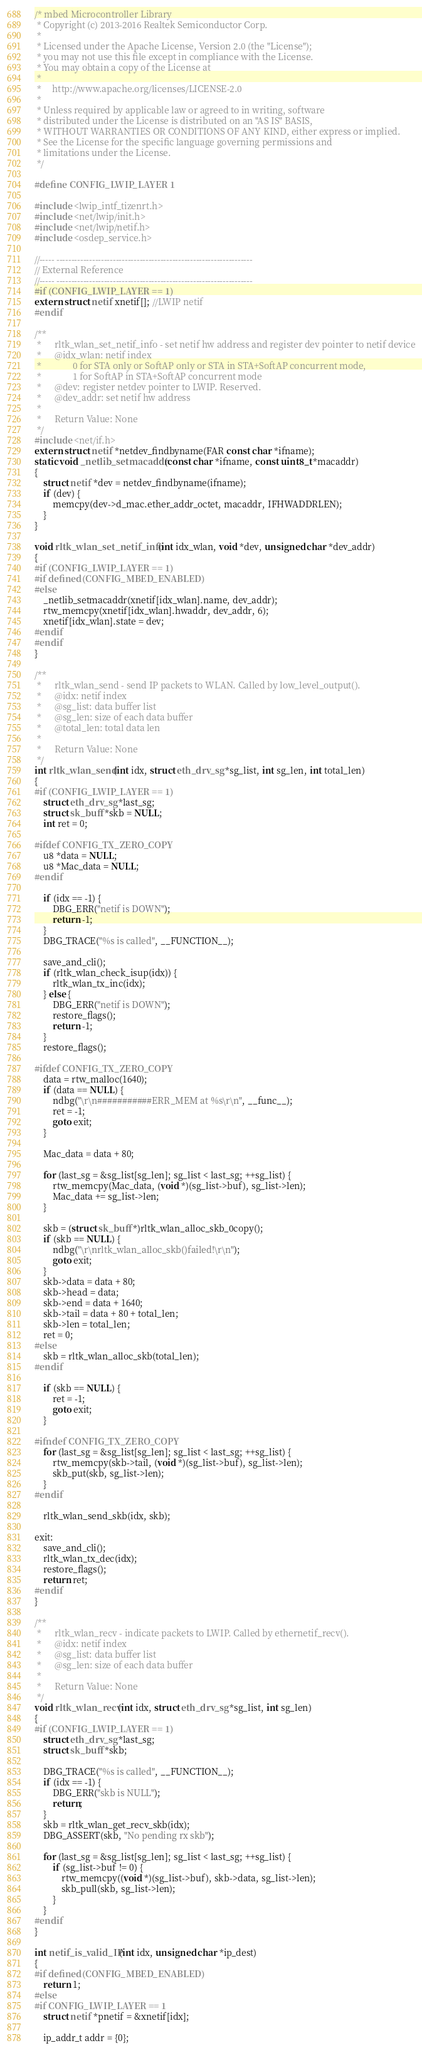<code> <loc_0><loc_0><loc_500><loc_500><_C_>/* mbed Microcontroller Library
 * Copyright (c) 2013-2016 Realtek Semiconductor Corp.
 *
 * Licensed under the Apache License, Version 2.0 (the "License");
 * you may not use this file except in compliance with the License.
 * You may obtain a copy of the License at
 *
 *     http://www.apache.org/licenses/LICENSE-2.0
 *
 * Unless required by applicable law or agreed to in writing, software
 * distributed under the License is distributed on an "AS IS" BASIS,
 * WITHOUT WARRANTIES OR CONDITIONS OF ANY KIND, either express or implied.
 * See the License for the specific language governing permissions and
 * limitations under the License.
 */

#define CONFIG_LWIP_LAYER 1

#include <lwip_intf_tizenrt.h>
#include <net/lwip/init.h>
#include <net/lwip/netif.h>
#include <osdep_service.h>

//----- ------------------------------------------------------------------
// External Reference
//----- ------------------------------------------------------------------
#if (CONFIG_LWIP_LAYER == 1)
extern struct netif xnetif[]; //LWIP netif
#endif

/**
 *      rltk_wlan_set_netif_info - set netif hw address and register dev pointer to netif device
 *      @idx_wlan: netif index
 *			    0 for STA only or SoftAP only or STA in STA+SoftAP concurrent mode,
 *			    1 for SoftAP in STA+SoftAP concurrent mode
 *      @dev: register netdev pointer to LWIP. Reserved.
 *      @dev_addr: set netif hw address
 *
 *      Return Value: None
 */
#include <net/if.h>
extern struct netif *netdev_findbyname(FAR const char *ifname);
static void _netlib_setmacaddr(const char *ifname, const uint8_t *macaddr)
{
	struct netif *dev = netdev_findbyname(ifname);
	if (dev) {
		memcpy(dev->d_mac.ether_addr_octet, macaddr, IFHWADDRLEN);
	}
}

void rltk_wlan_set_netif_info(int idx_wlan, void *dev, unsigned char *dev_addr)
{
#if (CONFIG_LWIP_LAYER == 1)
#if defined(CONFIG_MBED_ENABLED)
#else
	_netlib_setmacaddr(xnetif[idx_wlan].name, dev_addr);
	rtw_memcpy(xnetif[idx_wlan].hwaddr, dev_addr, 6);
	xnetif[idx_wlan].state = dev;
#endif
#endif
}

/**
 *      rltk_wlan_send - send IP packets to WLAN. Called by low_level_output().
 *      @idx: netif index
 *      @sg_list: data buffer list
 *      @sg_len: size of each data buffer
 *      @total_len: total data len
 *
 *      Return Value: None
 */
int rltk_wlan_send(int idx, struct eth_drv_sg *sg_list, int sg_len, int total_len)
{
#if (CONFIG_LWIP_LAYER == 1)
	struct eth_drv_sg *last_sg;
	struct sk_buff *skb = NULL;
	int ret = 0;

#ifdef CONFIG_TX_ZERO_COPY
	u8 *data = NULL;
	u8 *Mac_data = NULL;
#endif

	if (idx == -1) {
		DBG_ERR("netif is DOWN");
		return -1;
	}
	DBG_TRACE("%s is called", __FUNCTION__);

	save_and_cli();
	if (rltk_wlan_check_isup(idx)) {
		rltk_wlan_tx_inc(idx);
	} else {
		DBG_ERR("netif is DOWN");
		restore_flags();
		return -1;
	}
	restore_flags();

#ifdef CONFIG_TX_ZERO_COPY
	data = rtw_malloc(1640);
	if (data == NULL) {
		ndbg("\r\n###########ERR_MEM at %s\r\n", __func__);
		ret = -1;
		goto exit;
	}

	Mac_data = data + 80;

	for (last_sg = &sg_list[sg_len]; sg_list < last_sg; ++sg_list) {
		rtw_memcpy(Mac_data, (void *)(sg_list->buf), sg_list->len);
		Mac_data += sg_list->len;
	}

	skb = (struct sk_buff *)rltk_wlan_alloc_skb_0copy();
	if (skb == NULL) {
		ndbg("\r\nrltk_wlan_alloc_skb()failed!\r\n");
		goto exit;
	}
	skb->data = data + 80;
	skb->head = data;
	skb->end = data + 1640;
	skb->tail = data + 80 + total_len;
	skb->len = total_len;
	ret = 0;
#else
	skb = rltk_wlan_alloc_skb(total_len);
#endif

	if (skb == NULL) {
		ret = -1;
		goto exit;
	}

#ifndef CONFIG_TX_ZERO_COPY
	for (last_sg = &sg_list[sg_len]; sg_list < last_sg; ++sg_list) {
		rtw_memcpy(skb->tail, (void *)(sg_list->buf), sg_list->len);
		skb_put(skb, sg_list->len);
	}
#endif

	rltk_wlan_send_skb(idx, skb);

exit:
	save_and_cli();
	rltk_wlan_tx_dec(idx);
	restore_flags();
	return ret;
#endif
}

/**
 *      rltk_wlan_recv - indicate packets to LWIP. Called by ethernetif_recv().
 *      @idx: netif index
 *      @sg_list: data buffer list
 *      @sg_len: size of each data buffer
 *
 *      Return Value: None
 */
void rltk_wlan_recv(int idx, struct eth_drv_sg *sg_list, int sg_len)
{
#if (CONFIG_LWIP_LAYER == 1)
	struct eth_drv_sg *last_sg;
	struct sk_buff *skb;

	DBG_TRACE("%s is called", __FUNCTION__);
	if (idx == -1) {
		DBG_ERR("skb is NULL");
		return;
	}
	skb = rltk_wlan_get_recv_skb(idx);
	DBG_ASSERT(skb, "No pending rx skb");

	for (last_sg = &sg_list[sg_len]; sg_list < last_sg; ++sg_list) {
		if (sg_list->buf != 0) {
			rtw_memcpy((void *)(sg_list->buf), skb->data, sg_list->len);
			skb_pull(skb, sg_list->len);
		}
	}
#endif
}

int netif_is_valid_IP(int idx, unsigned char *ip_dest)
{
#if defined(CONFIG_MBED_ENABLED)
	return 1;
#else
#if CONFIG_LWIP_LAYER == 1
	struct netif *pnetif = &xnetif[idx];

	ip_addr_t addr = {0};
</code> 